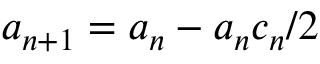Convert formula to latex. <formula><loc_0><loc_0><loc_500><loc_500>a _ { n + 1 } = a _ { n } - a _ { n } c _ { n } / 2 \,</formula> 